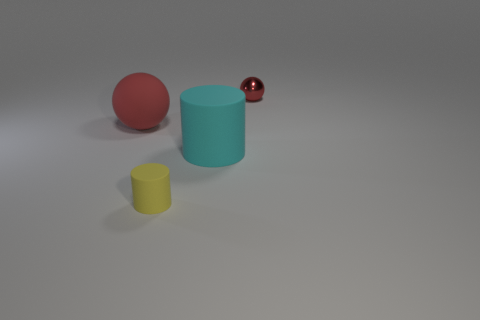Add 3 large cyan cylinders. How many objects exist? 7 Subtract all gray matte cubes. Subtract all matte cylinders. How many objects are left? 2 Add 2 large spheres. How many large spheres are left? 3 Add 4 cyan rubber objects. How many cyan rubber objects exist? 5 Subtract 0 brown blocks. How many objects are left? 4 